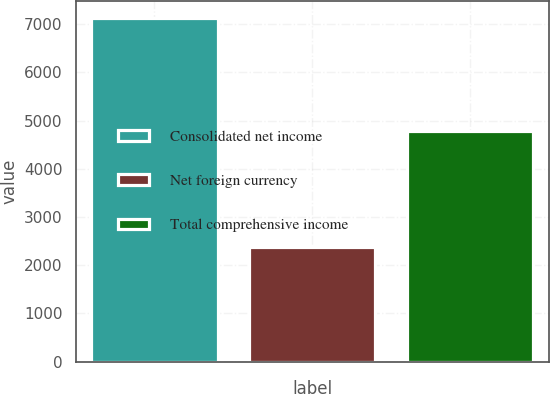Convert chart. <chart><loc_0><loc_0><loc_500><loc_500><bar_chart><fcel>Consolidated net income<fcel>Net foreign currency<fcel>Total comprehensive income<nl><fcel>7124<fcel>2382<fcel>4774<nl></chart> 